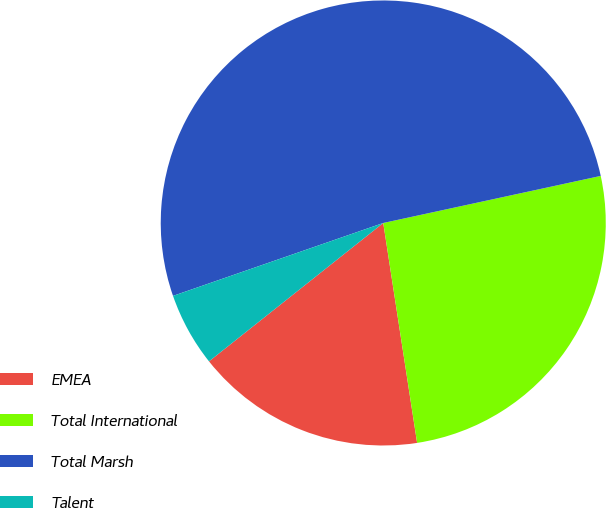<chart> <loc_0><loc_0><loc_500><loc_500><pie_chart><fcel>EMEA<fcel>Total International<fcel>Total Marsh<fcel>Talent<nl><fcel>16.75%<fcel>25.96%<fcel>51.92%<fcel>5.37%<nl></chart> 